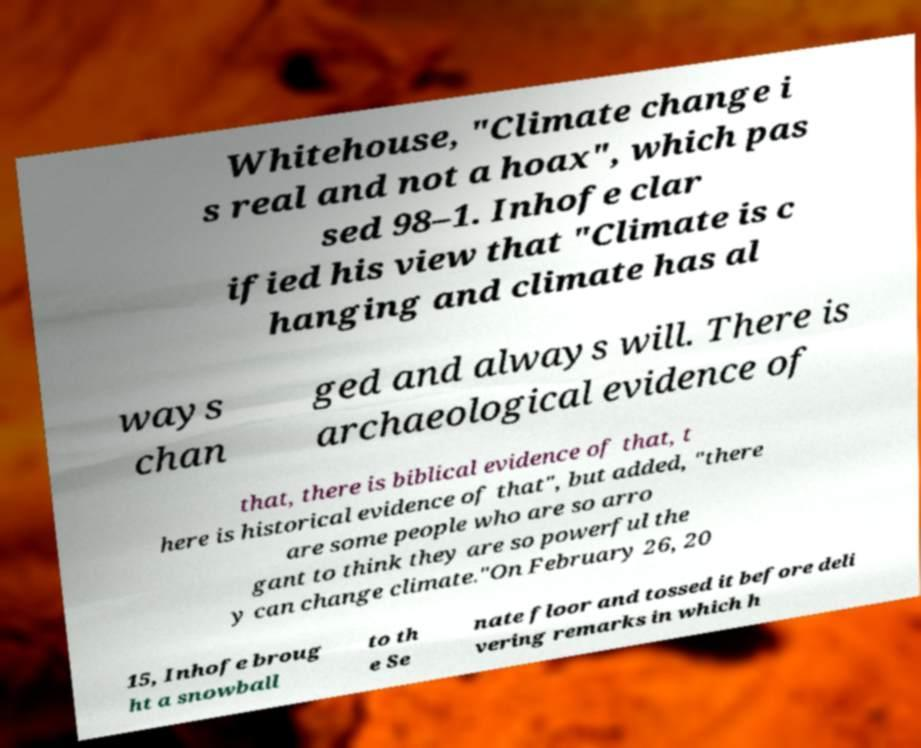Please identify and transcribe the text found in this image. Whitehouse, "Climate change i s real and not a hoax", which pas sed 98–1. Inhofe clar ified his view that "Climate is c hanging and climate has al ways chan ged and always will. There is archaeological evidence of that, there is biblical evidence of that, t here is historical evidence of that", but added, "there are some people who are so arro gant to think they are so powerful the y can change climate."On February 26, 20 15, Inhofe broug ht a snowball to th e Se nate floor and tossed it before deli vering remarks in which h 